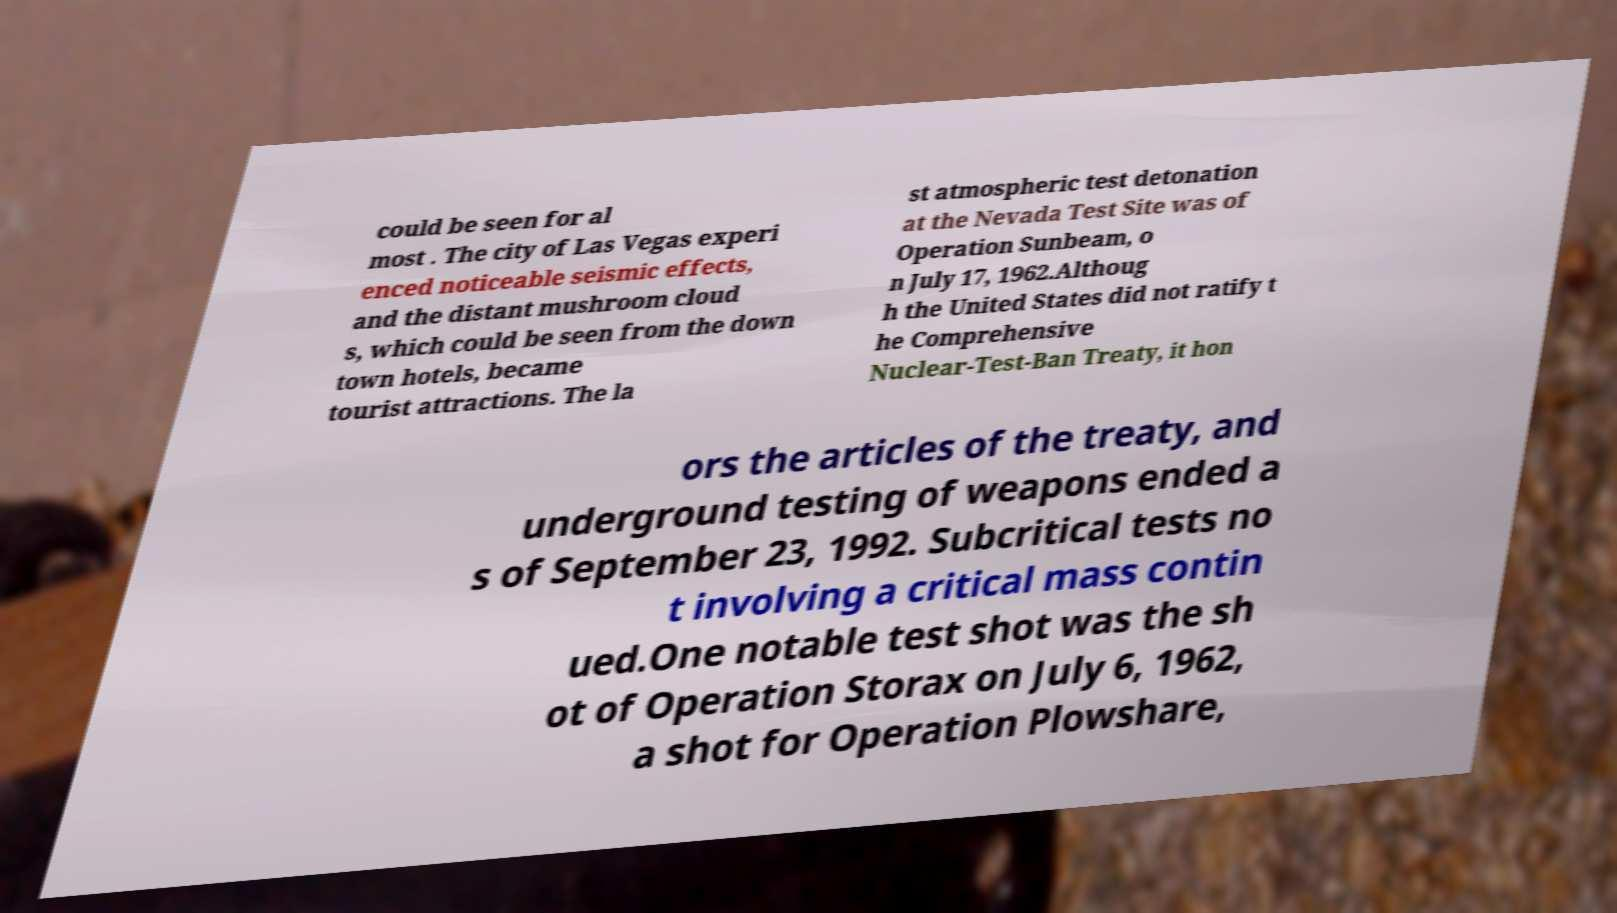What messages or text are displayed in this image? I need them in a readable, typed format. could be seen for al most . The city of Las Vegas experi enced noticeable seismic effects, and the distant mushroom cloud s, which could be seen from the down town hotels, became tourist attractions. The la st atmospheric test detonation at the Nevada Test Site was of Operation Sunbeam, o n July 17, 1962.Althoug h the United States did not ratify t he Comprehensive Nuclear-Test-Ban Treaty, it hon ors the articles of the treaty, and underground testing of weapons ended a s of September 23, 1992. Subcritical tests no t involving a critical mass contin ued.One notable test shot was the sh ot of Operation Storax on July 6, 1962, a shot for Operation Plowshare, 